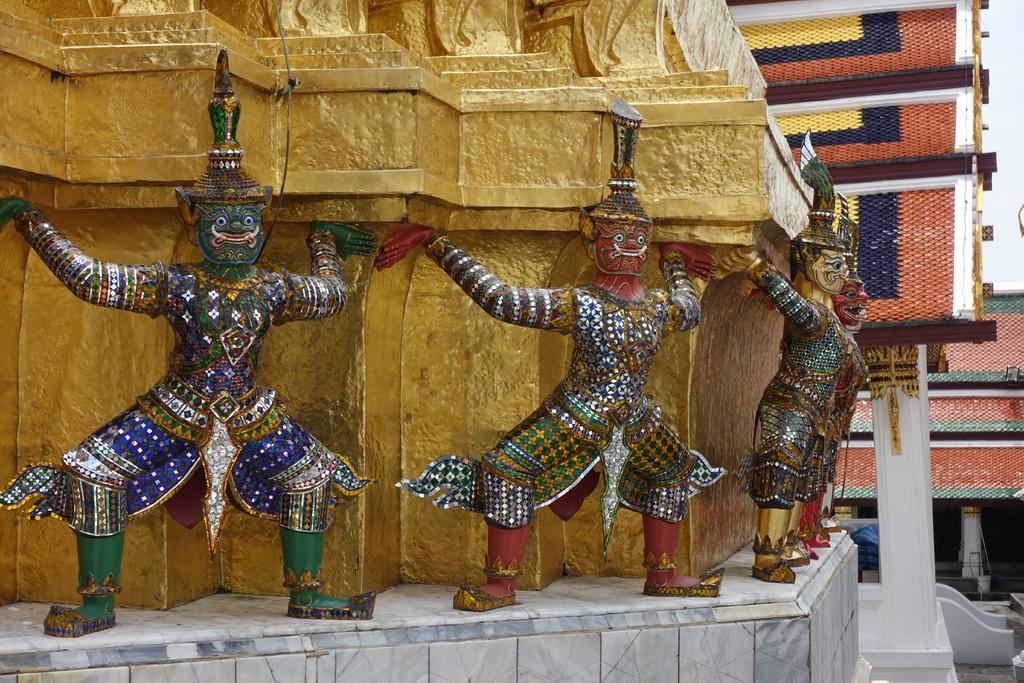What can be seen on the wall of the structure in the foreground? There are sculptures on the wall of a structure in the foreground. What is the appearance of the structure? The structure has gold paint on it. What is visible in the background of the image? In the background, there are shelters visible. What can be seen in the sky in the background? The sky is visible in the background. What type of poison is being used to paint the planes in the image? There are no planes present in the image, and therefore no poison or painting activity can be observed. What is the cause of the damage to the shelters in the image? There is no indication of damage to the shelters in the image, nor is there any information provided about the cause of any potential damage. 